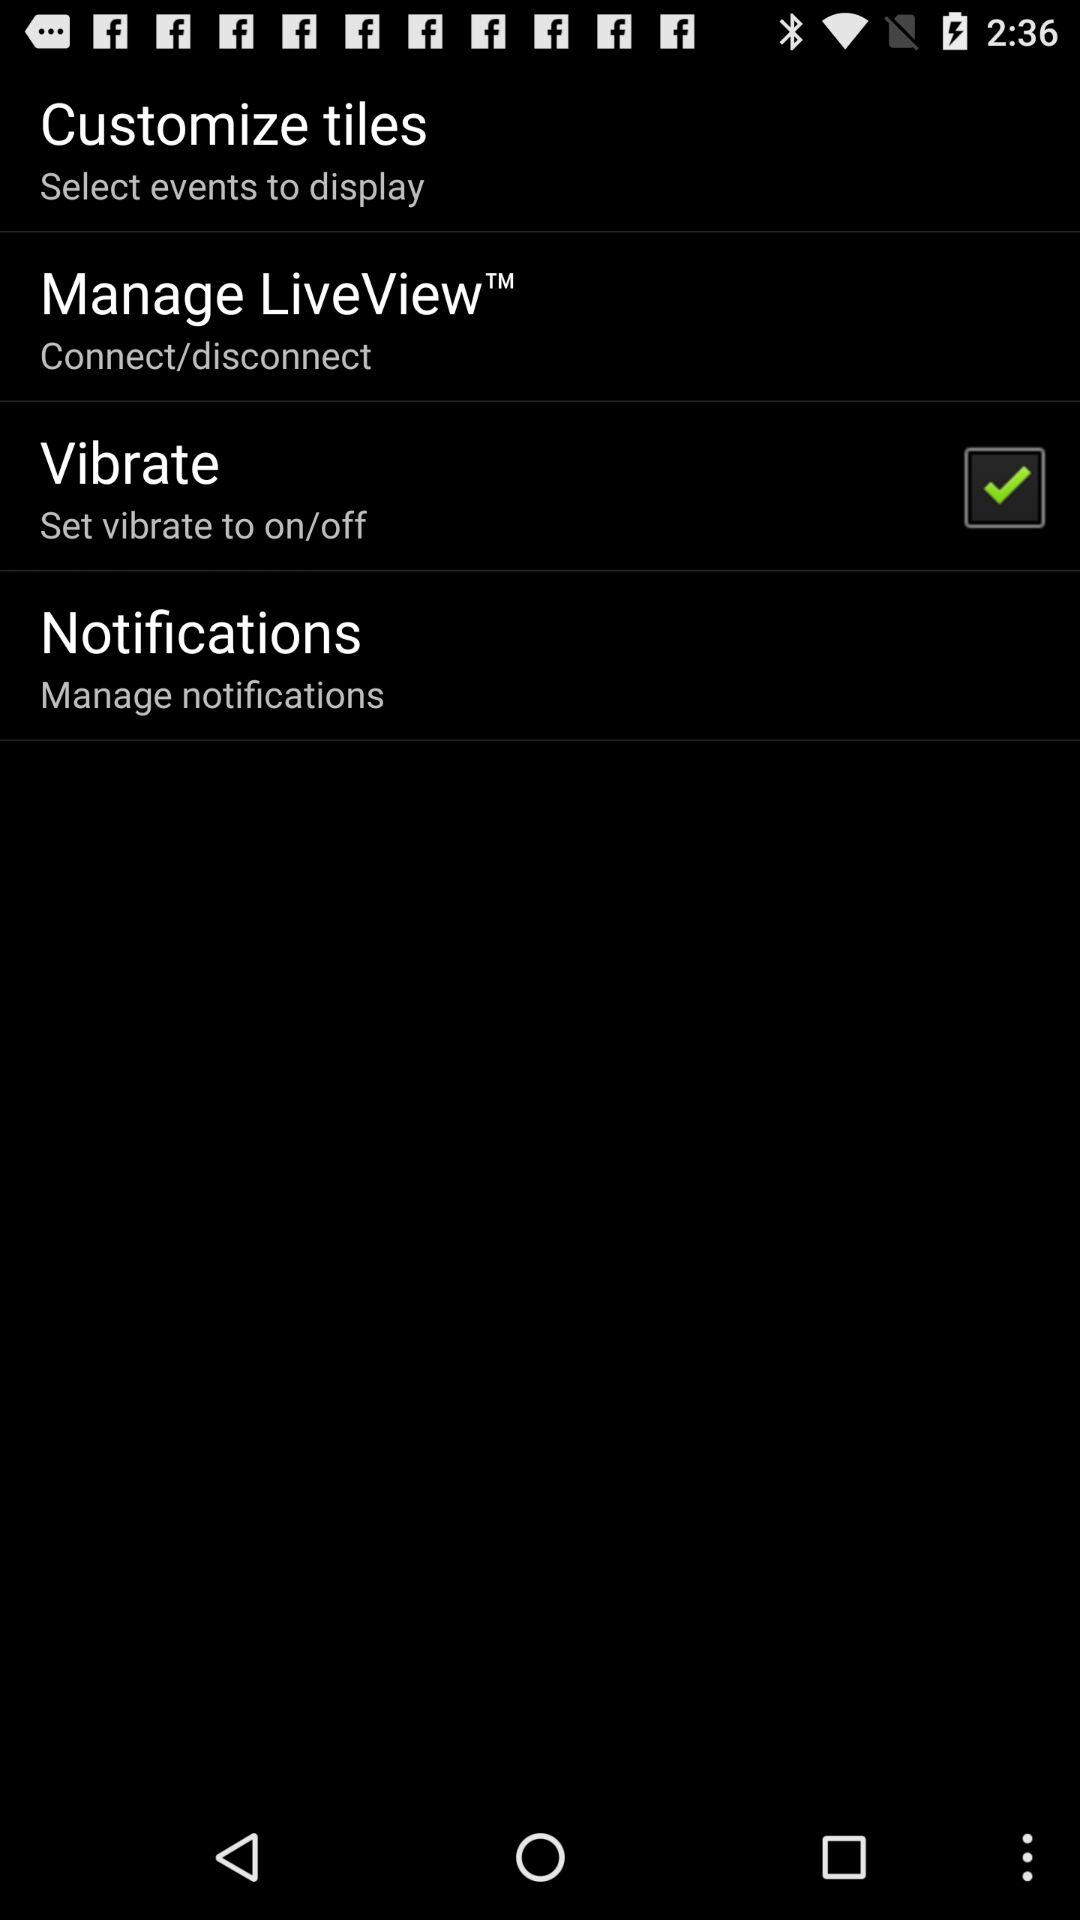What is the status of "Vibrate"? The status is "on". 